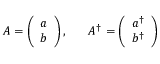<formula> <loc_0><loc_0><loc_500><loc_500>A = \left ( \begin{array} { c } { a } \\ { b } \end{array} \right ) , \, A ^ { \dagger } = \left ( \begin{array} { c } { { a ^ { \dagger } } } \\ { { b ^ { \dagger } } } \end{array} \right )</formula> 